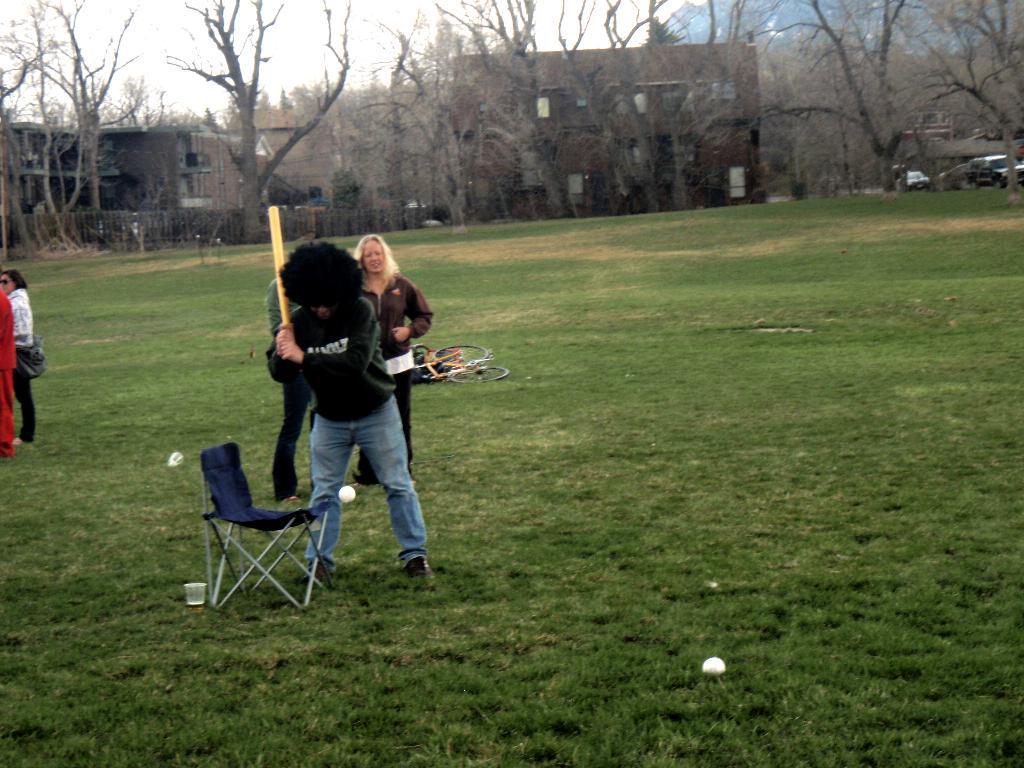In one or two sentences, can you explain what this image depicts? In this image I can see group of people standing. The person in front wearing green color shirt, blue color pant and holding some object. In front I can see a ball in white color and a chair in blue color, background I can see dried trees, buildings, and sky in white color. 